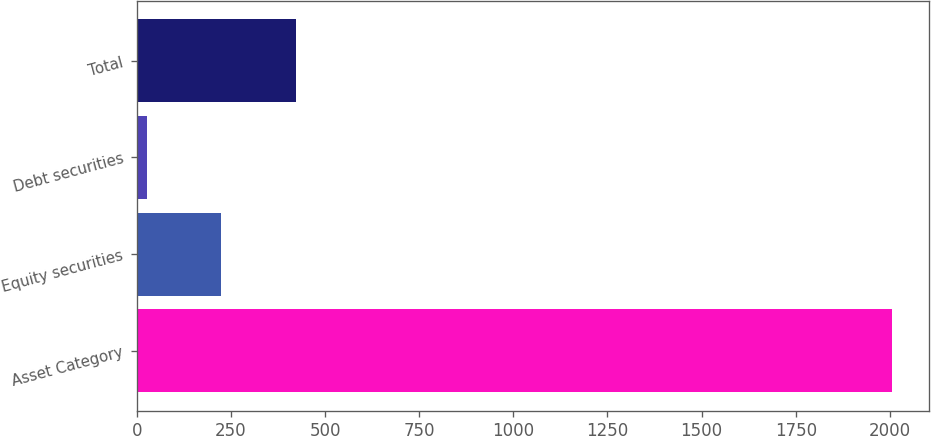Convert chart to OTSL. <chart><loc_0><loc_0><loc_500><loc_500><bar_chart><fcel>Asset Category<fcel>Equity securities<fcel>Debt securities<fcel>Total<nl><fcel>2005<fcel>224.8<fcel>27<fcel>422.6<nl></chart> 